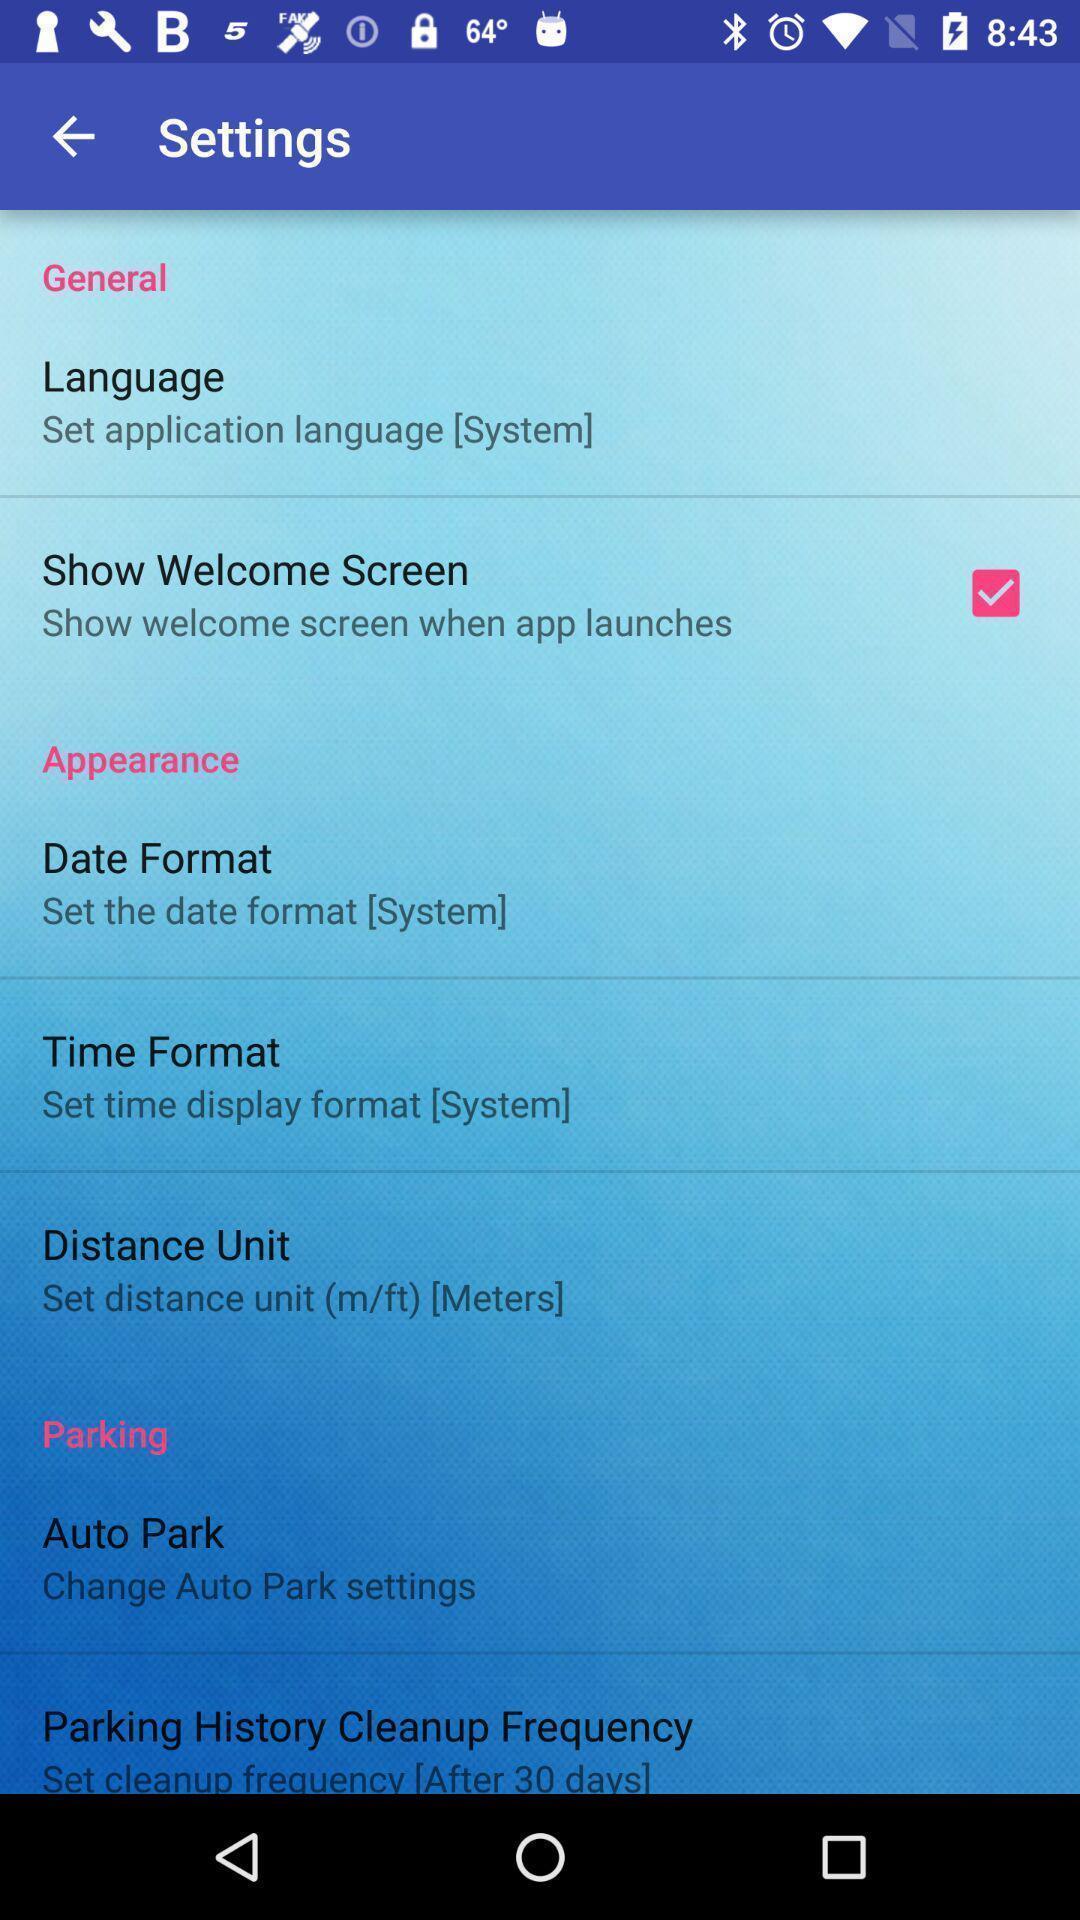Explain what's happening in this screen capture. Screen displaying options in settings app. 